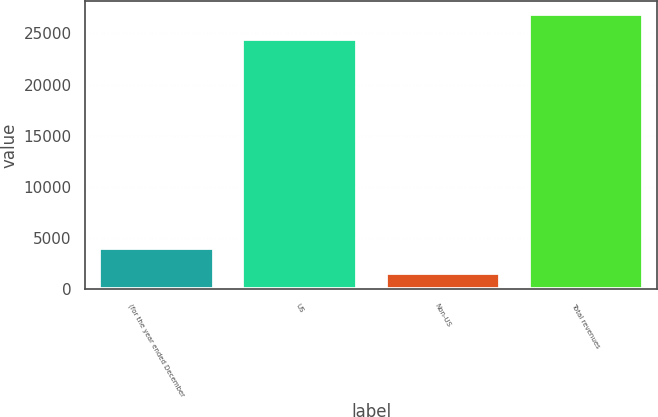Convert chart. <chart><loc_0><loc_0><loc_500><loc_500><bar_chart><fcel>(for the year ended December<fcel>US<fcel>Non-US<fcel>Total revenues<nl><fcel>4045.3<fcel>24413<fcel>1604<fcel>26854.3<nl></chart> 